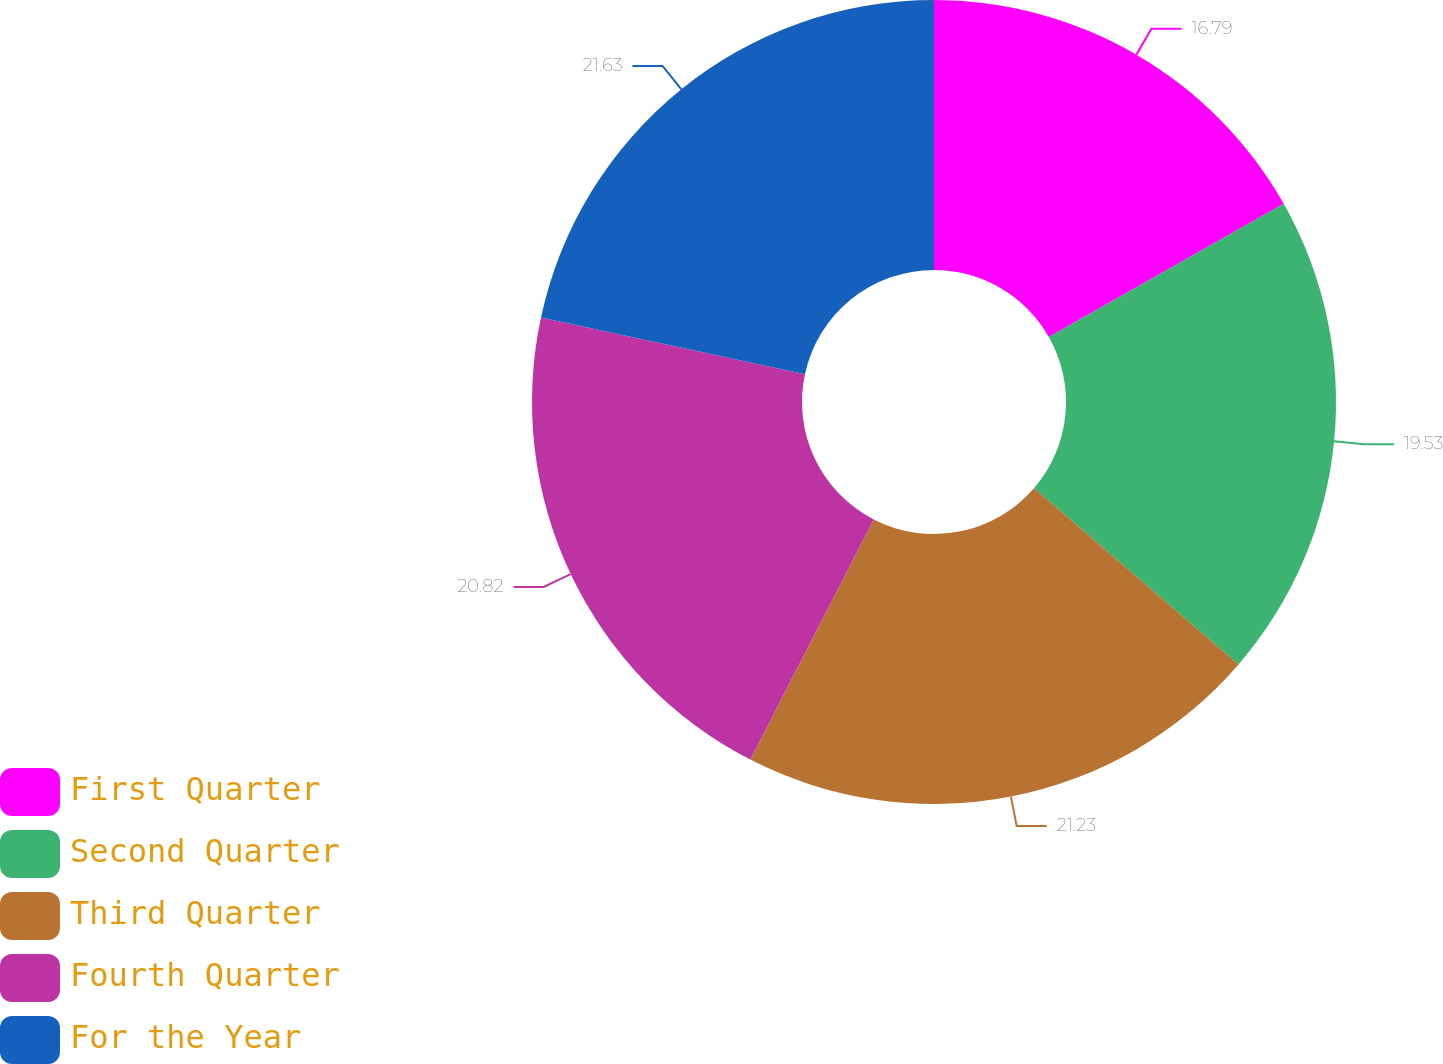<chart> <loc_0><loc_0><loc_500><loc_500><pie_chart><fcel>First Quarter<fcel>Second Quarter<fcel>Third Quarter<fcel>Fourth Quarter<fcel>For the Year<nl><fcel>16.79%<fcel>19.53%<fcel>21.23%<fcel>20.82%<fcel>21.63%<nl></chart> 